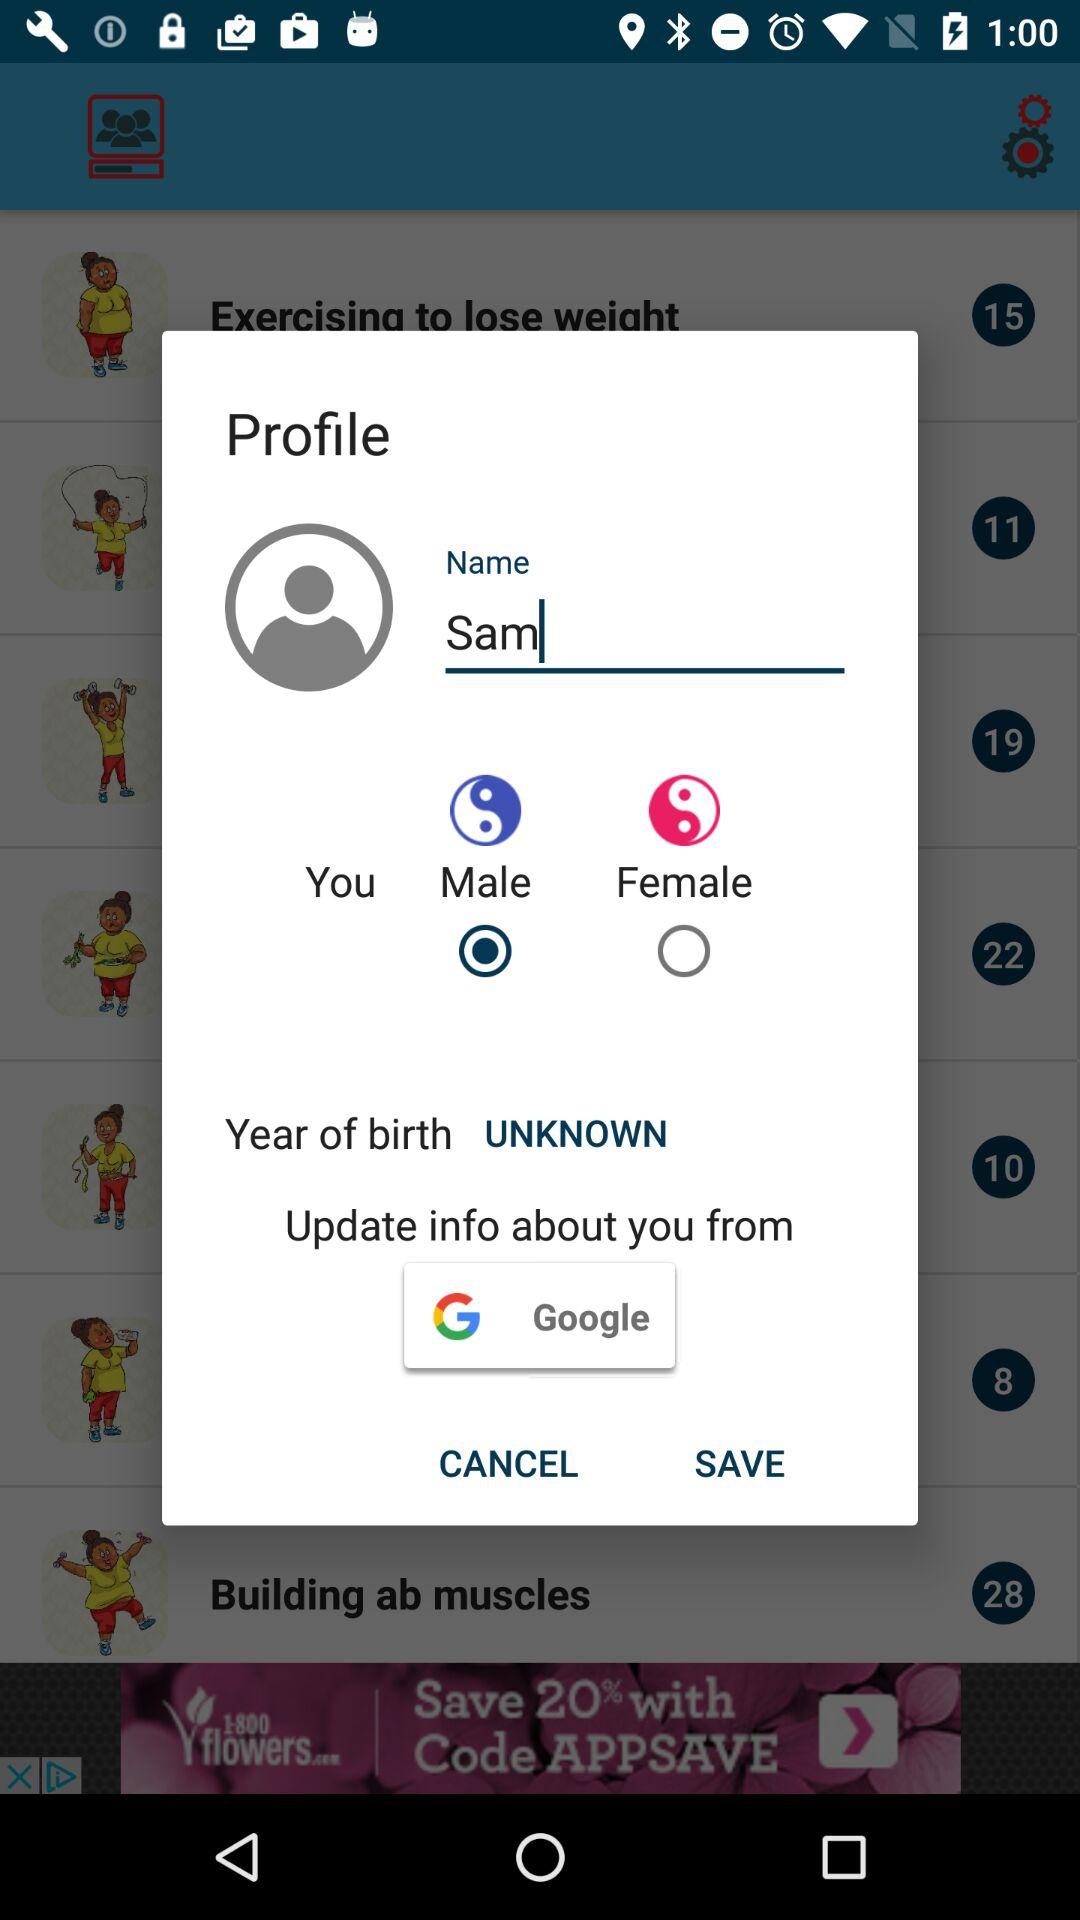From where is the information updated? We can update information from Google. 